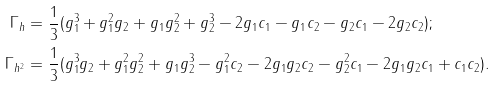<formula> <loc_0><loc_0><loc_500><loc_500>\Gamma _ { h } & = \frac { 1 } { 3 } ( g _ { 1 } ^ { 3 } + g _ { 1 } ^ { 2 } g _ { 2 } + g _ { 1 } g _ { 2 } ^ { 2 } + g _ { 2 } ^ { 3 } - 2 g _ { 1 } c _ { 1 } - g _ { 1 } c _ { 2 } - g _ { 2 } c _ { 1 } - 2 g _ { 2 } c _ { 2 } ) ; \\ \Gamma _ { h ^ { 2 } } & = \frac { 1 } { 3 } ( g _ { 1 } ^ { 3 } g _ { 2 } + g _ { 1 } ^ { 2 } g _ { 2 } ^ { 2 } + g _ { 1 } g _ { 2 } ^ { 3 } - g _ { 1 } ^ { 2 } c _ { 2 } - 2 g _ { 1 } g _ { 2 } c _ { 2 } - g _ { 2 } ^ { 2 } c _ { 1 } - 2 g _ { 1 } g _ { 2 } c _ { 1 } + c _ { 1 } c _ { 2 } ) .</formula> 